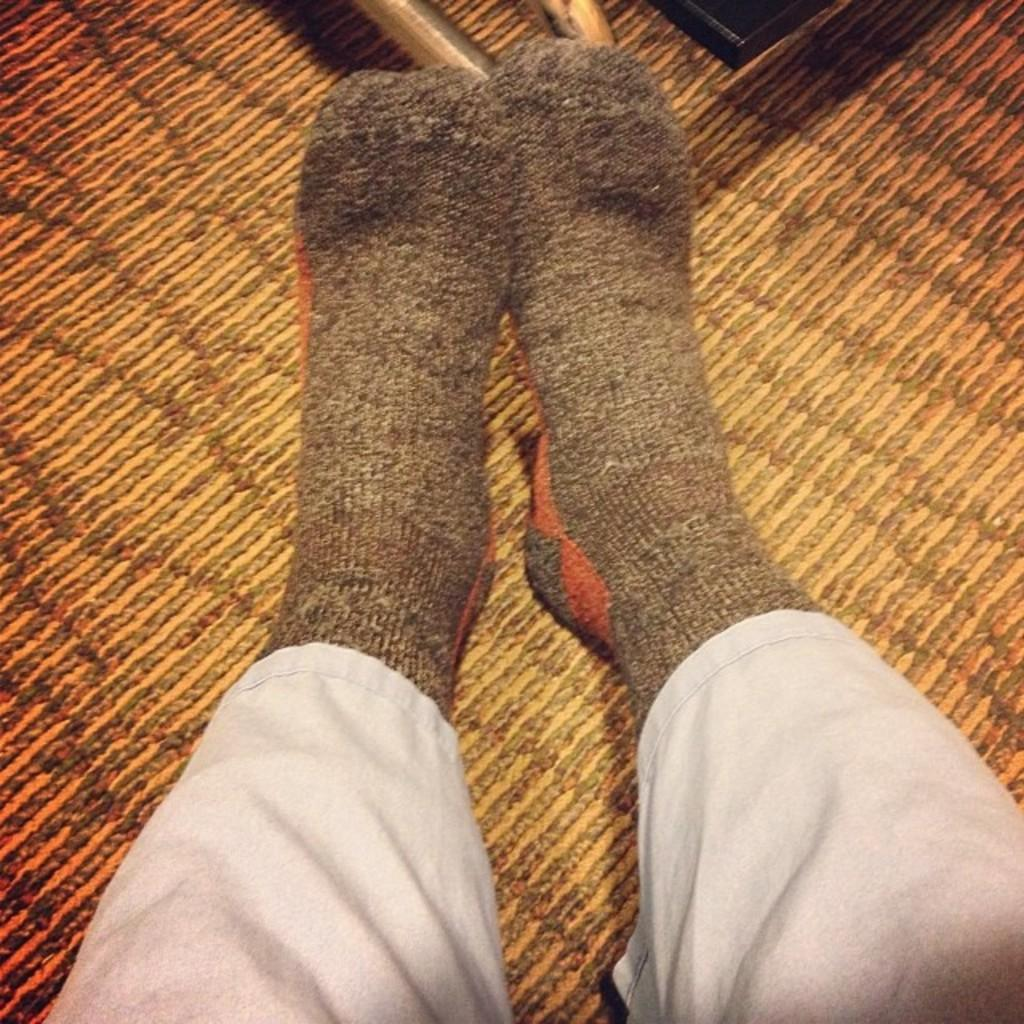What body part is visible in the image? There are a person's legs visible in the image. What type of clothing is the person wearing on their legs? The person is wearing socks. What type of flooring is the person's legs on? The legs are on a carpet floor. What appliance can be seen in the image? There is no appliance present in the image. 